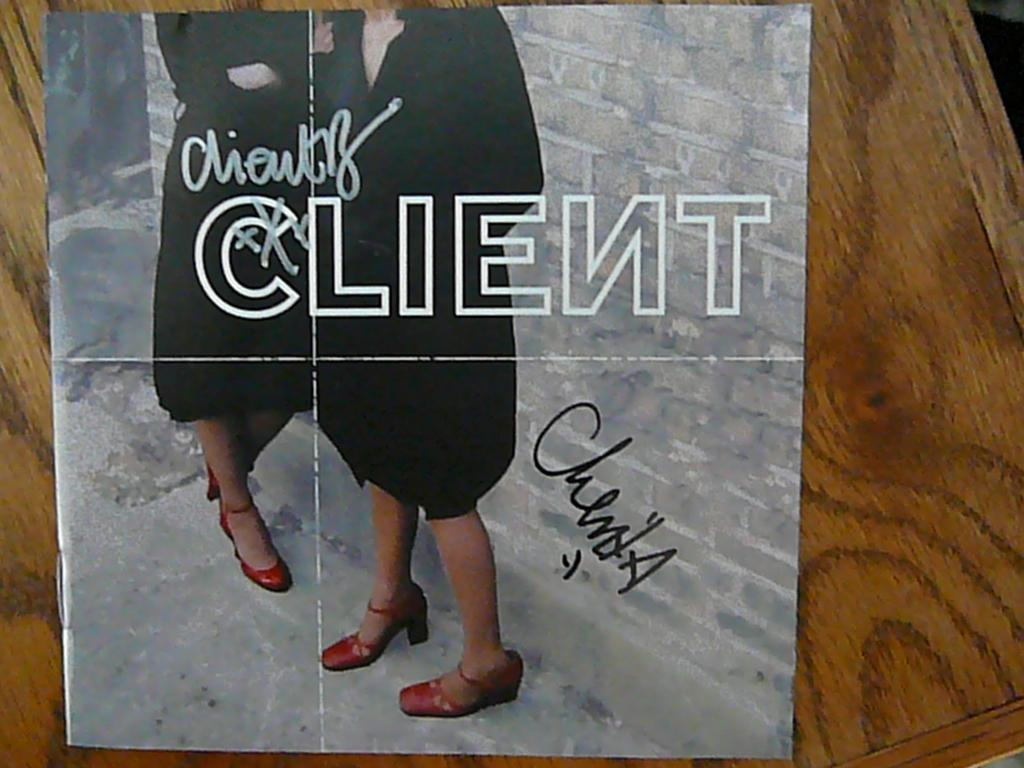What type of furniture is present in the image? There is a table in the image. What is placed on the table? There is a poster on the table. What is depicted on the poster? The poster features two women wearing colorful dresses. Are there any words or phrases on the poster? Yes, there is text written on the poster. How many pets are visible in the image? There are no pets present in the image. What type of stone is featured in the image? There is no stone present in the image. 